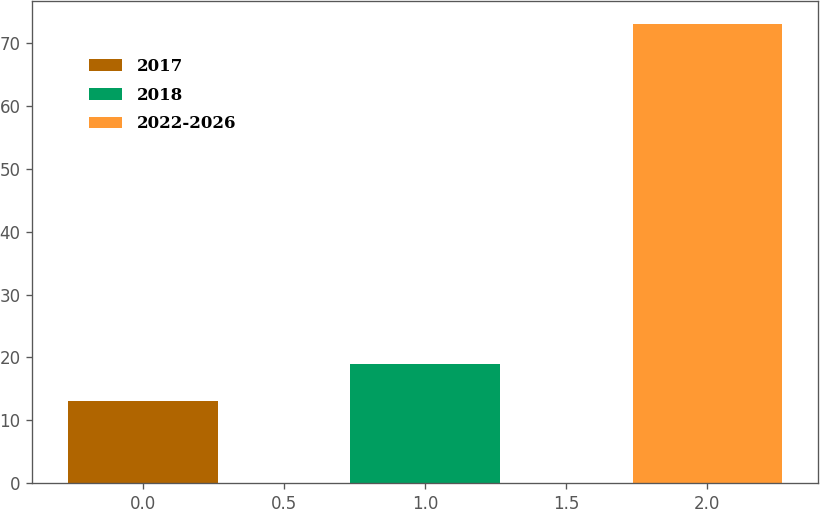Convert chart. <chart><loc_0><loc_0><loc_500><loc_500><bar_chart><fcel>2017<fcel>2018<fcel>2022-2026<nl><fcel>13<fcel>19<fcel>73<nl></chart> 